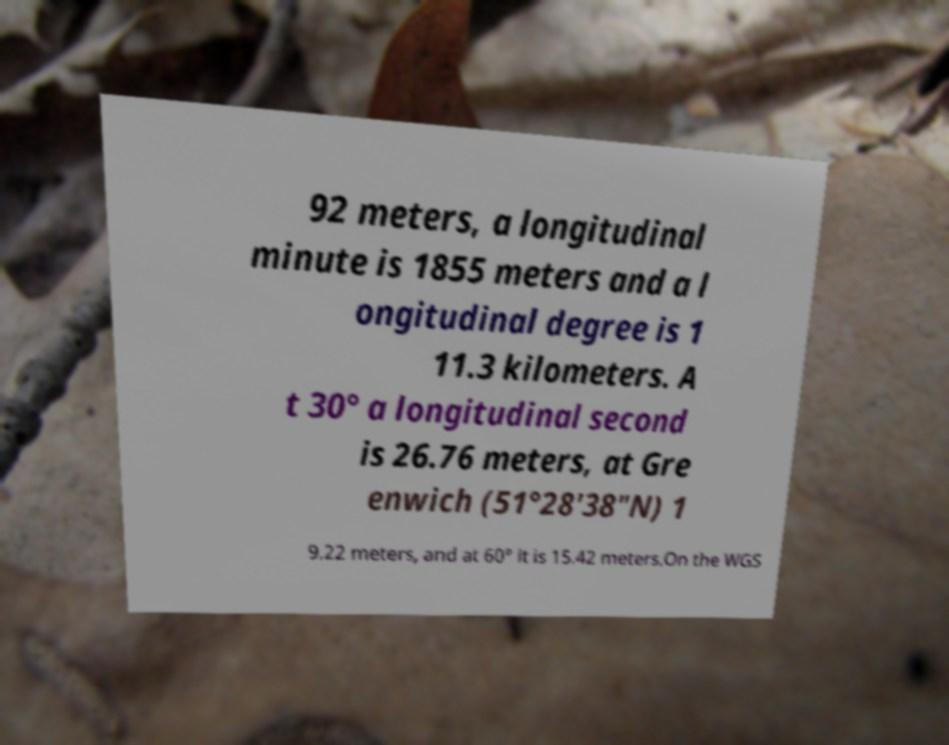Can you accurately transcribe the text from the provided image for me? 92 meters, a longitudinal minute is 1855 meters and a l ongitudinal degree is 1 11.3 kilometers. A t 30° a longitudinal second is 26.76 meters, at Gre enwich (51°28′38″N) 1 9.22 meters, and at 60° it is 15.42 meters.On the WGS 